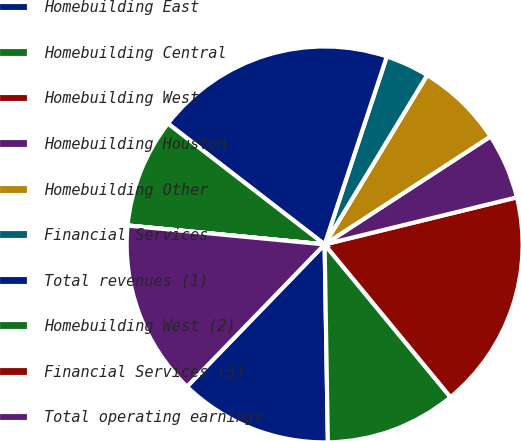Convert chart. <chart><loc_0><loc_0><loc_500><loc_500><pie_chart><fcel>Homebuilding East<fcel>Homebuilding Central<fcel>Homebuilding West<fcel>Homebuilding Houston<fcel>Homebuilding Other<fcel>Financial Services<fcel>Total revenues (1)<fcel>Homebuilding West (2)<fcel>Financial Services (3)<fcel>Total operating earnings<nl><fcel>12.5%<fcel>10.71%<fcel>17.85%<fcel>5.36%<fcel>7.15%<fcel>3.58%<fcel>19.63%<fcel>8.93%<fcel>0.01%<fcel>14.28%<nl></chart> 